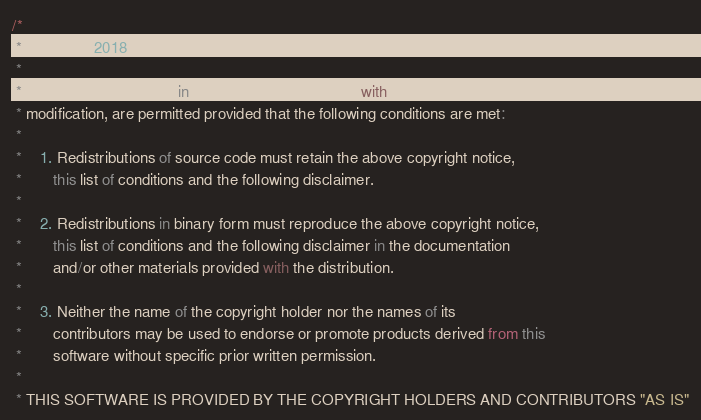Convert code to text. <code><loc_0><loc_0><loc_500><loc_500><_JavaScript_>/*
 * Copyright 2018 Apple Inc.
 *
 * Redistribution and use in source and binary forms, with or without
 * modification, are permitted provided that the following conditions are met:
 *
 *    1. Redistributions of source code must retain the above copyright notice,
 *       this list of conditions and the following disclaimer.
 *
 *    2. Redistributions in binary form must reproduce the above copyright notice,
 *       this list of conditions and the following disclaimer in the documentation
 *       and/or other materials provided with the distribution.
 *
 *    3. Neither the name of the copyright holder nor the names of its
 *       contributors may be used to endorse or promote products derived from this
 *       software without specific prior written permission.
 *
 * THIS SOFTWARE IS PROVIDED BY THE COPYRIGHT HOLDERS AND CONTRIBUTORS "AS IS"</code> 